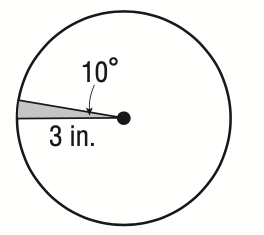Question: What is the area of the sector?
Choices:
A. \frac { \pi } { 6 }
B. \frac { \pi } { 4 }
C. \frac { 3 \pi } { 5 }
D. \frac { 9 \pi } { 10 }
Answer with the letter. Answer: B 